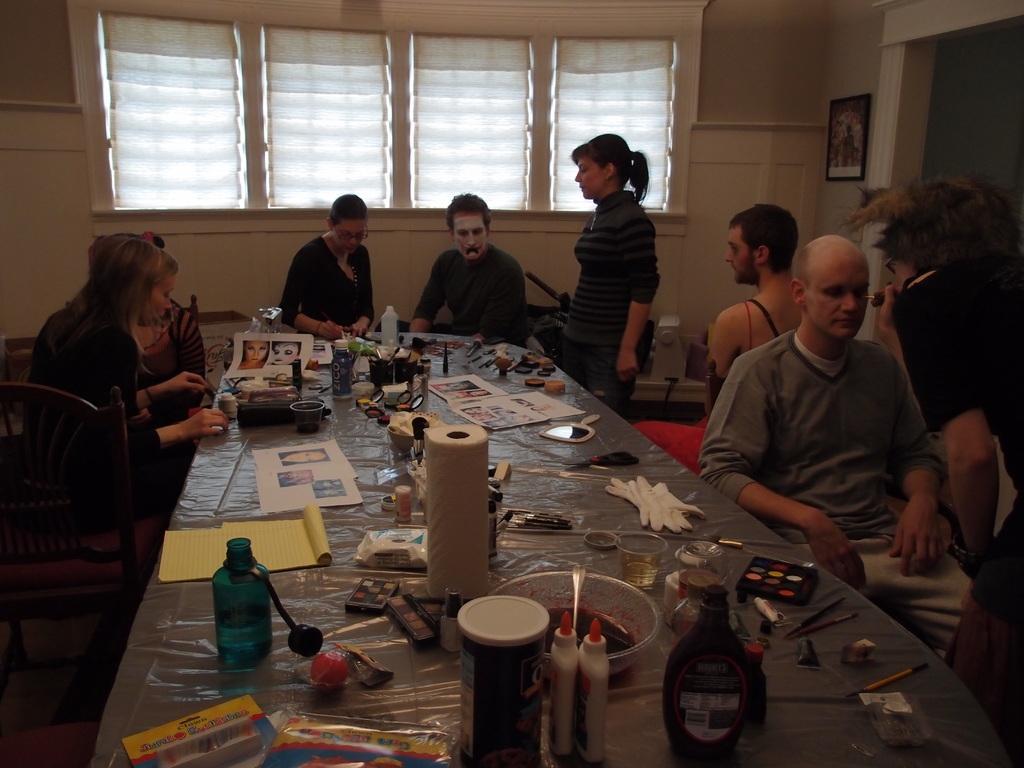In one or two sentences, can you explain what this image depicts? There is a woman sitting on a chair on the left side and she is applying some cream to a woman. There are two people who are sitting at the center. There is a man who is sitting on a chair. There is another who is standing in front of this man giving some treatment to his eyes. 